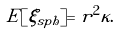Convert formula to latex. <formula><loc_0><loc_0><loc_500><loc_500>E [ \xi _ { s p h } ] = r ^ { 2 } \kappa .</formula> 